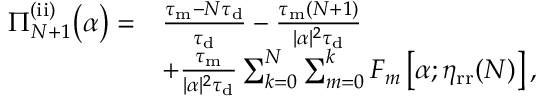<formula> <loc_0><loc_0><loc_500><loc_500>\begin{array} { r l } { \Pi _ { N + 1 } ^ { ( i i ) } \left ( \alpha \right ) = } & { \frac { \tau _ { m } - N \tau _ { d } } { \tau _ { d } } - \frac { \tau _ { m } ( N + 1 ) } { | \alpha | ^ { 2 } \tau _ { d } } } \\ & { + \frac { \tau _ { m } } { | \alpha | ^ { 2 } \tau _ { d } } \sum _ { k = 0 } ^ { N } \sum _ { m = 0 } ^ { k } F _ { m } \left [ \alpha ; \eta _ { r r } ( N ) \right ] , } \end{array}</formula> 